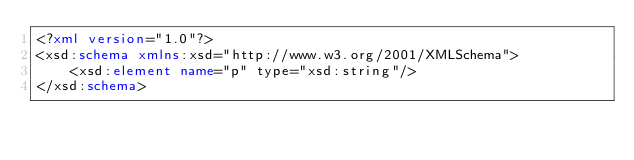<code> <loc_0><loc_0><loc_500><loc_500><_XML_><?xml version="1.0"?>
<xsd:schema xmlns:xsd="http://www.w3.org/2001/XMLSchema">
    <xsd:element name="p" type="xsd:string"/>
</xsd:schema> </code> 